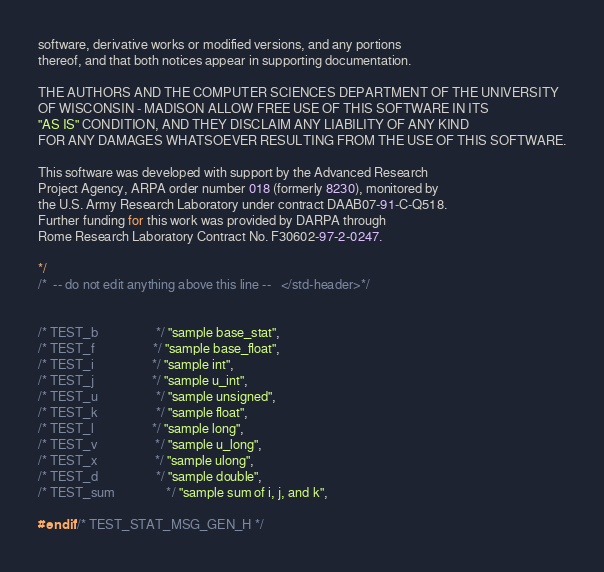<code> <loc_0><loc_0><loc_500><loc_500><_C_>software, derivative works or modified versions, and any portions
thereof, and that both notices appear in supporting documentation.

THE AUTHORS AND THE COMPUTER SCIENCES DEPARTMENT OF THE UNIVERSITY
OF WISCONSIN - MADISON ALLOW FREE USE OF THIS SOFTWARE IN ITS
"AS IS" CONDITION, AND THEY DISCLAIM ANY LIABILITY OF ANY KIND
FOR ANY DAMAGES WHATSOEVER RESULTING FROM THE USE OF THIS SOFTWARE.

This software was developed with support by the Advanced Research
Project Agency, ARPA order number 018 (formerly 8230), monitored by
the U.S. Army Research Laboratory under contract DAAB07-91-C-Q518.
Further funding for this work was provided by DARPA through
Rome Research Laboratory Contract No. F30602-97-2-0247.

*/
/*  -- do not edit anything above this line --   </std-header>*/


/* TEST_b                  */ "sample base_stat",
/* TEST_f                  */ "sample base_float",
/* TEST_i                  */ "sample int",
/* TEST_j                  */ "sample u_int",
/* TEST_u                  */ "sample unsigned",
/* TEST_k                  */ "sample float",
/* TEST_l                  */ "sample long",
/* TEST_v                  */ "sample u_long",
/* TEST_x                  */ "sample ulong",
/* TEST_d                  */ "sample double",
/* TEST_sum                */ "sample sum of i, j, and k",

#endif /* TEST_STAT_MSG_GEN_H */
</code> 